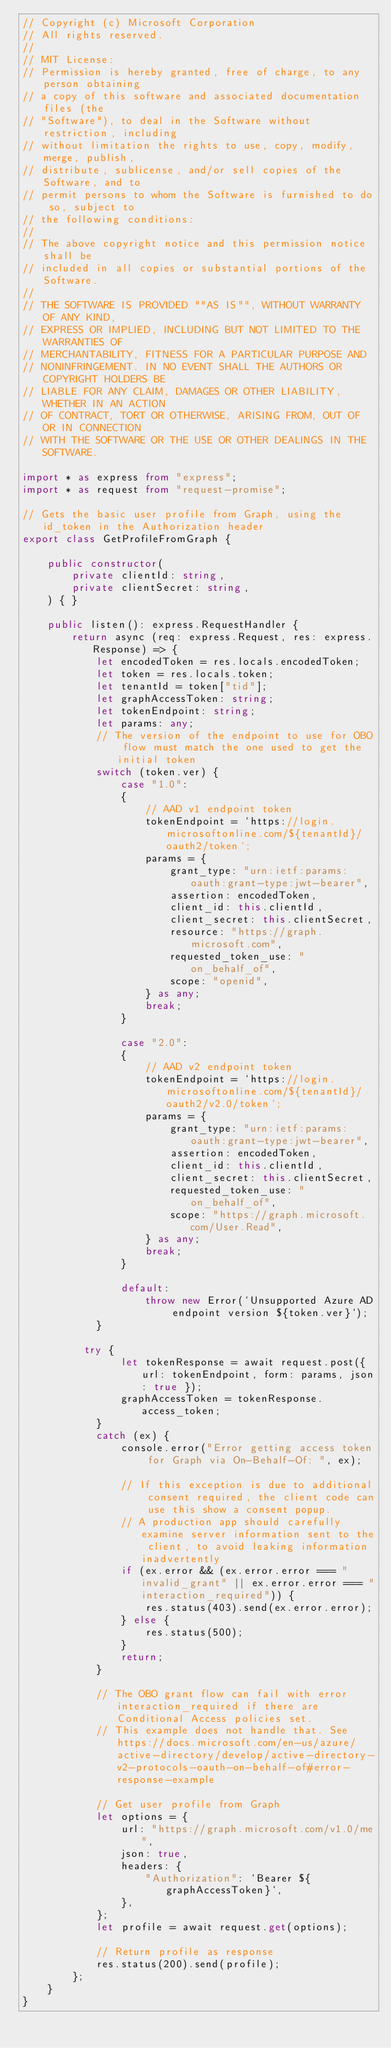Convert code to text. <code><loc_0><loc_0><loc_500><loc_500><_TypeScript_>// Copyright (c) Microsoft Corporation
// All rights reserved.
//
// MIT License:
// Permission is hereby granted, free of charge, to any person obtaining
// a copy of this software and associated documentation files (the
// "Software"), to deal in the Software without restriction, including
// without limitation the rights to use, copy, modify, merge, publish,
// distribute, sublicense, and/or sell copies of the Software, and to
// permit persons to whom the Software is furnished to do so, subject to
// the following conditions:
//
// The above copyright notice and this permission notice shall be
// included in all copies or substantial portions of the Software.
//
// THE SOFTWARE IS PROVIDED ""AS IS"", WITHOUT WARRANTY OF ANY KIND,
// EXPRESS OR IMPLIED, INCLUDING BUT NOT LIMITED TO THE WARRANTIES OF
// MERCHANTABILITY, FITNESS FOR A PARTICULAR PURPOSE AND
// NONINFRINGEMENT. IN NO EVENT SHALL THE AUTHORS OR COPYRIGHT HOLDERS BE
// LIABLE FOR ANY CLAIM, DAMAGES OR OTHER LIABILITY, WHETHER IN AN ACTION
// OF CONTRACT, TORT OR OTHERWISE, ARISING FROM, OUT OF OR IN CONNECTION
// WITH THE SOFTWARE OR THE USE OR OTHER DEALINGS IN THE SOFTWARE.

import * as express from "express";
import * as request from "request-promise";

// Gets the basic user profile from Graph, using the id_token in the Authorization header
export class GetProfileFromGraph {

    public constructor(
        private clientId: string,
        private clientSecret: string,
    ) { }

    public listen(): express.RequestHandler {
        return async (req: express.Request, res: express.Response) => {
            let encodedToken = res.locals.encodedToken;
            let token = res.locals.token;
            let tenantId = token["tid"];
            let graphAccessToken: string;
            let tokenEndpoint: string;
            let params: any;
            // The version of the endpoint to use for OBO flow must match the one used to get the initial token
            switch (token.ver) {
                case "1.0":
                {
                    // AAD v1 endpoint token
                    tokenEndpoint = `https://login.microsoftonline.com/${tenantId}/oauth2/token`;
                    params = {
                        grant_type: "urn:ietf:params:oauth:grant-type:jwt-bearer",
                        assertion: encodedToken,
                        client_id: this.clientId,
                        client_secret: this.clientSecret,
                        resource: "https://graph.microsoft.com",
                        requested_token_use: "on_behalf_of",
                        scope: "openid",
                    } as any;
                    break;
                }

                case "2.0":
                {
                    // AAD v2 endpoint token
                    tokenEndpoint = `https://login.microsoftonline.com/${tenantId}/oauth2/v2.0/token`;
                    params = {
                        grant_type: "urn:ietf:params:oauth:grant-type:jwt-bearer",
                        assertion: encodedToken,
                        client_id: this.clientId,
                        client_secret: this.clientSecret,
                        requested_token_use: "on_behalf_of",
                        scope: "https://graph.microsoft.com/User.Read",
                    } as any;
                    break;
                }

                default:
                    throw new Error(`Unsupported Azure AD endpoint version ${token.ver}`);
            }

          try {
                let tokenResponse = await request.post({ url: tokenEndpoint, form: params, json: true });
                graphAccessToken = tokenResponse.access_token;
            }
            catch (ex) {
                console.error("Error getting access token for Graph via On-Behalf-Of: ", ex);

                // If this exception is due to additional consent required, the client code can use this show a consent popup.
                // A production app should carefully examine server information sent to the client, to avoid leaking information inadvertently
                if (ex.error && (ex.error.error === "invalid_grant" || ex.error.error === "interaction_required")) {
                    res.status(403).send(ex.error.error);
                } else {
                    res.status(500);
                }
                return;
            }

            // The OBO grant flow can fail with error interaction_required if there are Conditional Access policies set.
            // This example does not handle that. See https://docs.microsoft.com/en-us/azure/active-directory/develop/active-directory-v2-protocols-oauth-on-behalf-of#error-response-example

            // Get user profile from Graph
            let options = {
                url: "https://graph.microsoft.com/v1.0/me",
                json: true,
                headers: {
                    "Authorization": `Bearer ${graphAccessToken}`,
                },
            };
            let profile = await request.get(options);

            // Return profile as response
            res.status(200).send(profile);
        };
    }
}
</code> 